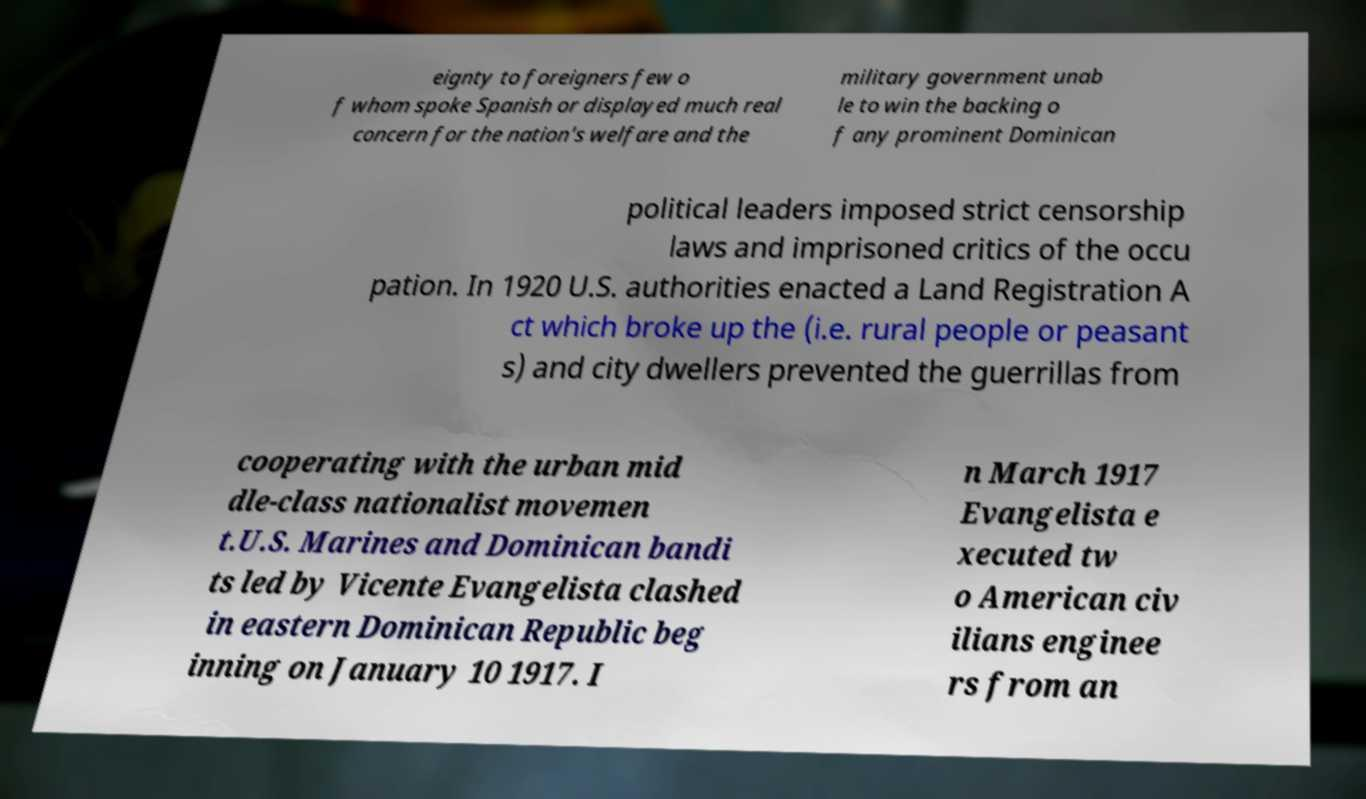I need the written content from this picture converted into text. Can you do that? eignty to foreigners few o f whom spoke Spanish or displayed much real concern for the nation's welfare and the military government unab le to win the backing o f any prominent Dominican political leaders imposed strict censorship laws and imprisoned critics of the occu pation. In 1920 U.S. authorities enacted a Land Registration A ct which broke up the (i.e. rural people or peasant s) and city dwellers prevented the guerrillas from cooperating with the urban mid dle-class nationalist movemen t.U.S. Marines and Dominican bandi ts led by Vicente Evangelista clashed in eastern Dominican Republic beg inning on January 10 1917. I n March 1917 Evangelista e xecuted tw o American civ ilians enginee rs from an 